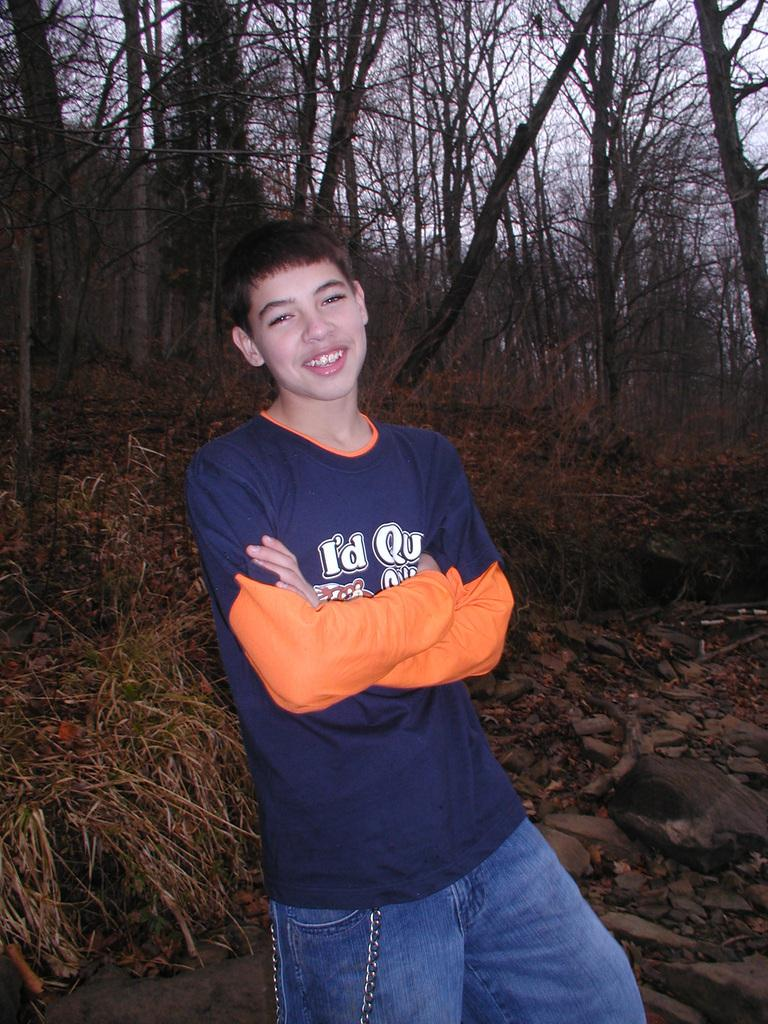<image>
Offer a succinct explanation of the picture presented. A young boy stands with his arms crossed while wearing a shirt that says I'd 